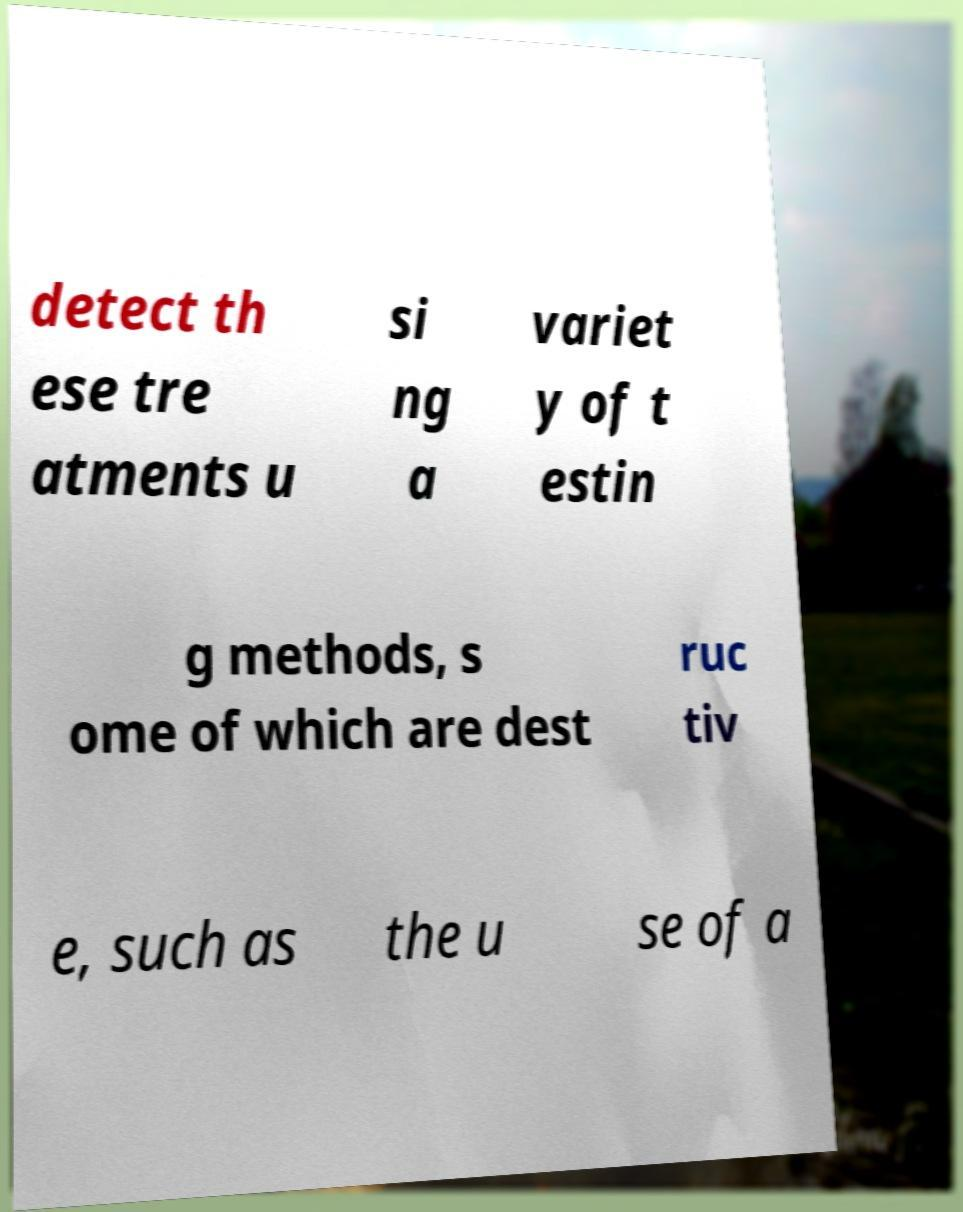What messages or text are displayed in this image? I need them in a readable, typed format. detect th ese tre atments u si ng a variet y of t estin g methods, s ome of which are dest ruc tiv e, such as the u se of a 